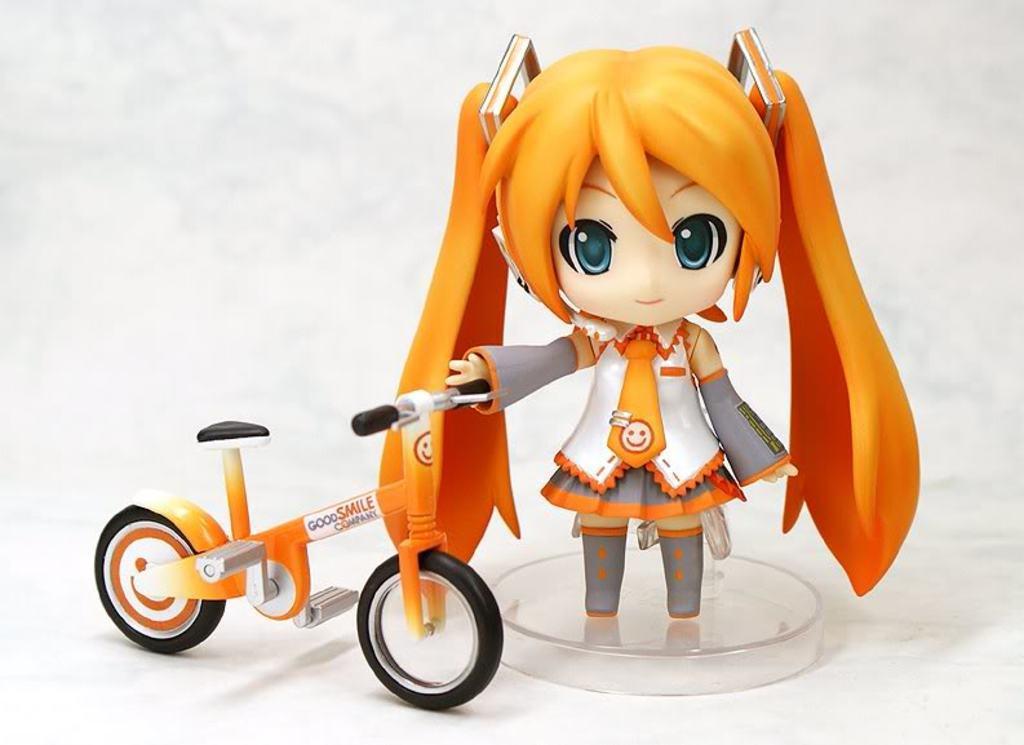In one or two sentences, can you explain what this image depicts? In this image I can see a doll and I can see this doll is holding a cycle. Here I can see something is written and I can see white colour in background. 